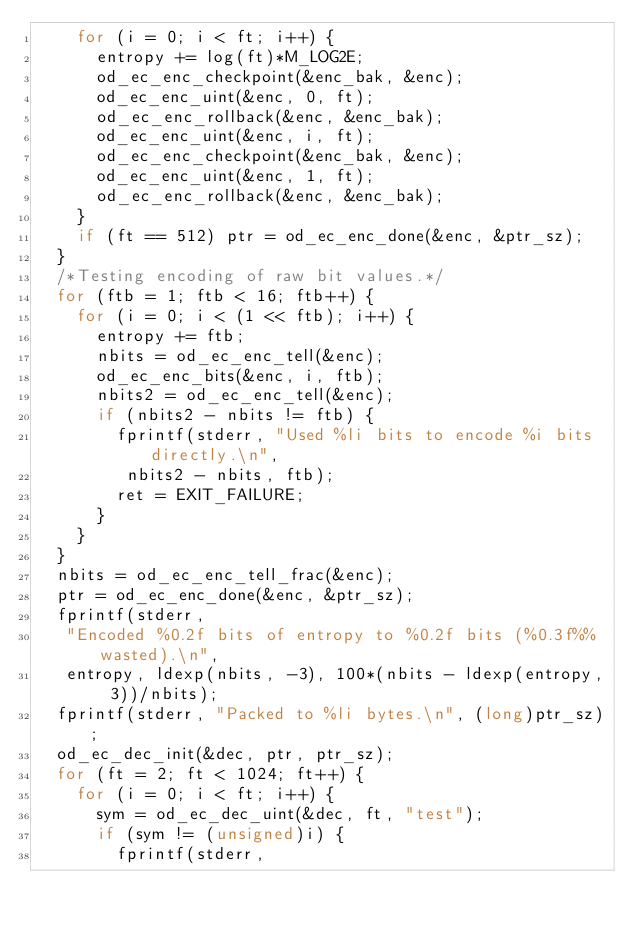Convert code to text. <code><loc_0><loc_0><loc_500><loc_500><_C_>    for (i = 0; i < ft; i++) {
      entropy += log(ft)*M_LOG2E;
      od_ec_enc_checkpoint(&enc_bak, &enc);
      od_ec_enc_uint(&enc, 0, ft);
      od_ec_enc_rollback(&enc, &enc_bak);
      od_ec_enc_uint(&enc, i, ft);
      od_ec_enc_checkpoint(&enc_bak, &enc);
      od_ec_enc_uint(&enc, 1, ft);
      od_ec_enc_rollback(&enc, &enc_bak);
    }
    if (ft == 512) ptr = od_ec_enc_done(&enc, &ptr_sz);
  }
  /*Testing encoding of raw bit values.*/
  for (ftb = 1; ftb < 16; ftb++) {
    for (i = 0; i < (1 << ftb); i++) {
      entropy += ftb;
      nbits = od_ec_enc_tell(&enc);
      od_ec_enc_bits(&enc, i, ftb);
      nbits2 = od_ec_enc_tell(&enc);
      if (nbits2 - nbits != ftb) {
        fprintf(stderr, "Used %li bits to encode %i bits directly.\n",
         nbits2 - nbits, ftb);
        ret = EXIT_FAILURE;
      }
    }
  }
  nbits = od_ec_enc_tell_frac(&enc);
  ptr = od_ec_enc_done(&enc, &ptr_sz);
  fprintf(stderr,
   "Encoded %0.2f bits of entropy to %0.2f bits (%0.3f%% wasted).\n",
   entropy, ldexp(nbits, -3), 100*(nbits - ldexp(entropy, 3))/nbits);
  fprintf(stderr, "Packed to %li bytes.\n", (long)ptr_sz);
  od_ec_dec_init(&dec, ptr, ptr_sz);
  for (ft = 2; ft < 1024; ft++) {
    for (i = 0; i < ft; i++) {
      sym = od_ec_dec_uint(&dec, ft, "test");
      if (sym != (unsigned)i) {
        fprintf(stderr,</code> 